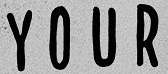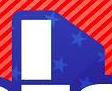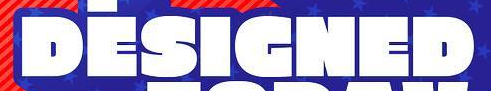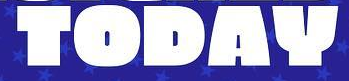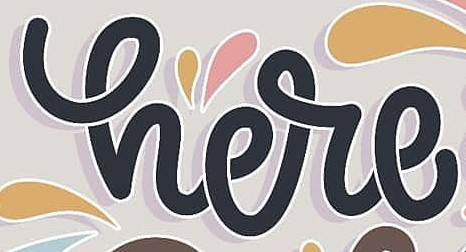Read the text from these images in sequence, separated by a semicolon. YOUR; I; DESIGNED; TODAY; here 